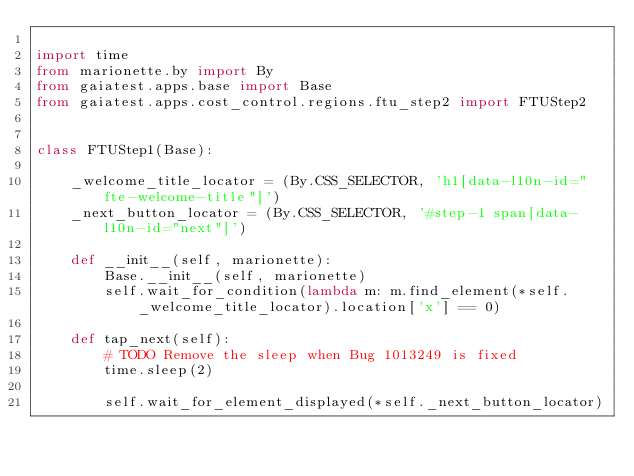<code> <loc_0><loc_0><loc_500><loc_500><_Python_>
import time
from marionette.by import By
from gaiatest.apps.base import Base
from gaiatest.apps.cost_control.regions.ftu_step2 import FTUStep2


class FTUStep1(Base):

    _welcome_title_locator = (By.CSS_SELECTOR, 'h1[data-l10n-id="fte-welcome-title"]')
    _next_button_locator = (By.CSS_SELECTOR, '#step-1 span[data-l10n-id="next"]')

    def __init__(self, marionette):
        Base.__init__(self, marionette)
        self.wait_for_condition(lambda m: m.find_element(*self._welcome_title_locator).location['x'] == 0)

    def tap_next(self):
        # TODO Remove the sleep when Bug 1013249 is fixed
        time.sleep(2)

        self.wait_for_element_displayed(*self._next_button_locator)</code> 